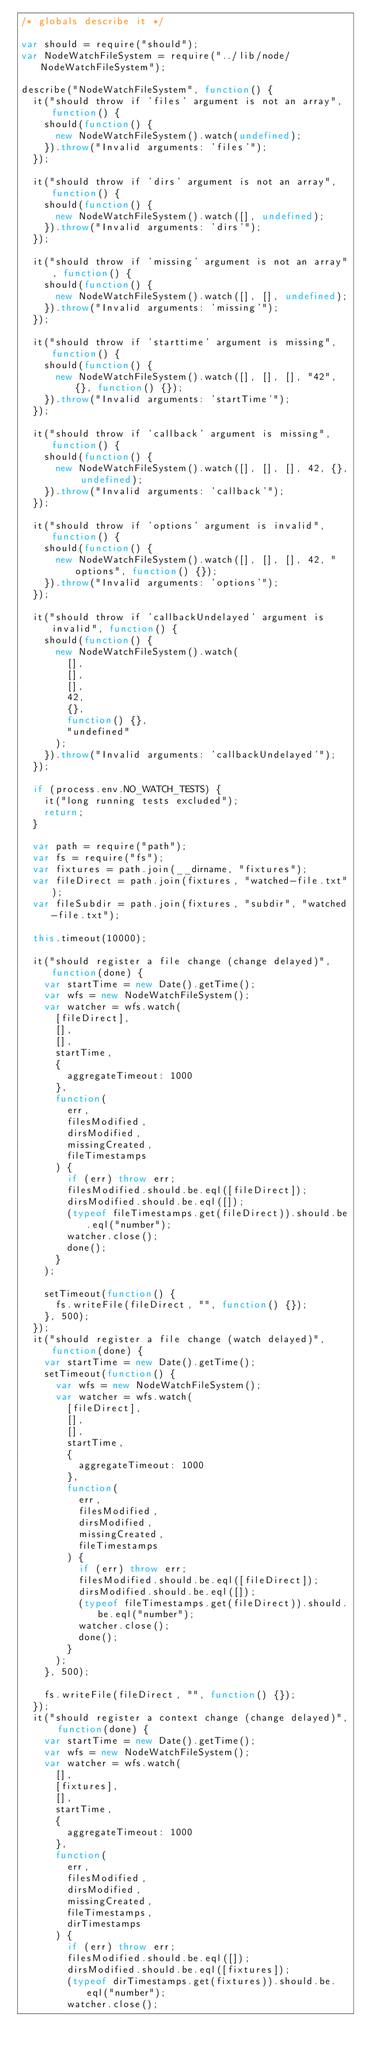Convert code to text. <code><loc_0><loc_0><loc_500><loc_500><_JavaScript_>/* globals describe it */

var should = require("should");
var NodeWatchFileSystem = require("../lib/node/NodeWatchFileSystem");

describe("NodeWatchFileSystem", function() {
	it("should throw if 'files' argument is not an array", function() {
		should(function() {
			new NodeWatchFileSystem().watch(undefined);
		}).throw("Invalid arguments: 'files'");
	});

	it("should throw if 'dirs' argument is not an array", function() {
		should(function() {
			new NodeWatchFileSystem().watch([], undefined);
		}).throw("Invalid arguments: 'dirs'");
	});

	it("should throw if 'missing' argument is not an array", function() {
		should(function() {
			new NodeWatchFileSystem().watch([], [], undefined);
		}).throw("Invalid arguments: 'missing'");
	});

	it("should throw if 'starttime' argument is missing", function() {
		should(function() {
			new NodeWatchFileSystem().watch([], [], [], "42", {}, function() {});
		}).throw("Invalid arguments: 'startTime'");
	});

	it("should throw if 'callback' argument is missing", function() {
		should(function() {
			new NodeWatchFileSystem().watch([], [], [], 42, {}, undefined);
		}).throw("Invalid arguments: 'callback'");
	});

	it("should throw if 'options' argument is invalid", function() {
		should(function() {
			new NodeWatchFileSystem().watch([], [], [], 42, "options", function() {});
		}).throw("Invalid arguments: 'options'");
	});

	it("should throw if 'callbackUndelayed' argument is invalid", function() {
		should(function() {
			new NodeWatchFileSystem().watch(
				[],
				[],
				[],
				42,
				{},
				function() {},
				"undefined"
			);
		}).throw("Invalid arguments: 'callbackUndelayed'");
	});

	if (process.env.NO_WATCH_TESTS) {
		it("long running tests excluded");
		return;
	}

	var path = require("path");
	var fs = require("fs");
	var fixtures = path.join(__dirname, "fixtures");
	var fileDirect = path.join(fixtures, "watched-file.txt");
	var fileSubdir = path.join(fixtures, "subdir", "watched-file.txt");

	this.timeout(10000);

	it("should register a file change (change delayed)", function(done) {
		var startTime = new Date().getTime();
		var wfs = new NodeWatchFileSystem();
		var watcher = wfs.watch(
			[fileDirect],
			[],
			[],
			startTime,
			{
				aggregateTimeout: 1000
			},
			function(
				err,
				filesModified,
				dirsModified,
				missingCreated,
				fileTimestamps
			) {
				if (err) throw err;
				filesModified.should.be.eql([fileDirect]);
				dirsModified.should.be.eql([]);
				(typeof fileTimestamps.get(fileDirect)).should.be.eql("number");
				watcher.close();
				done();
			}
		);

		setTimeout(function() {
			fs.writeFile(fileDirect, "", function() {});
		}, 500);
	});
	it("should register a file change (watch delayed)", function(done) {
		var startTime = new Date().getTime();
		setTimeout(function() {
			var wfs = new NodeWatchFileSystem();
			var watcher = wfs.watch(
				[fileDirect],
				[],
				[],
				startTime,
				{
					aggregateTimeout: 1000
				},
				function(
					err,
					filesModified,
					dirsModified,
					missingCreated,
					fileTimestamps
				) {
					if (err) throw err;
					filesModified.should.be.eql([fileDirect]);
					dirsModified.should.be.eql([]);
					(typeof fileTimestamps.get(fileDirect)).should.be.eql("number");
					watcher.close();
					done();
				}
			);
		}, 500);

		fs.writeFile(fileDirect, "", function() {});
	});
	it("should register a context change (change delayed)", function(done) {
		var startTime = new Date().getTime();
		var wfs = new NodeWatchFileSystem();
		var watcher = wfs.watch(
			[],
			[fixtures],
			[],
			startTime,
			{
				aggregateTimeout: 1000
			},
			function(
				err,
				filesModified,
				dirsModified,
				missingCreated,
				fileTimestamps,
				dirTimestamps
			) {
				if (err) throw err;
				filesModified.should.be.eql([]);
				dirsModified.should.be.eql([fixtures]);
				(typeof dirTimestamps.get(fixtures)).should.be.eql("number");
				watcher.close();</code> 